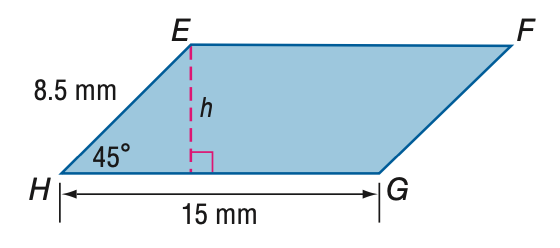Question: Find the area of \parallelogram E F G H.
Choices:
A. 64
B. 90
C. 110
D. 127
Answer with the letter. Answer: B 